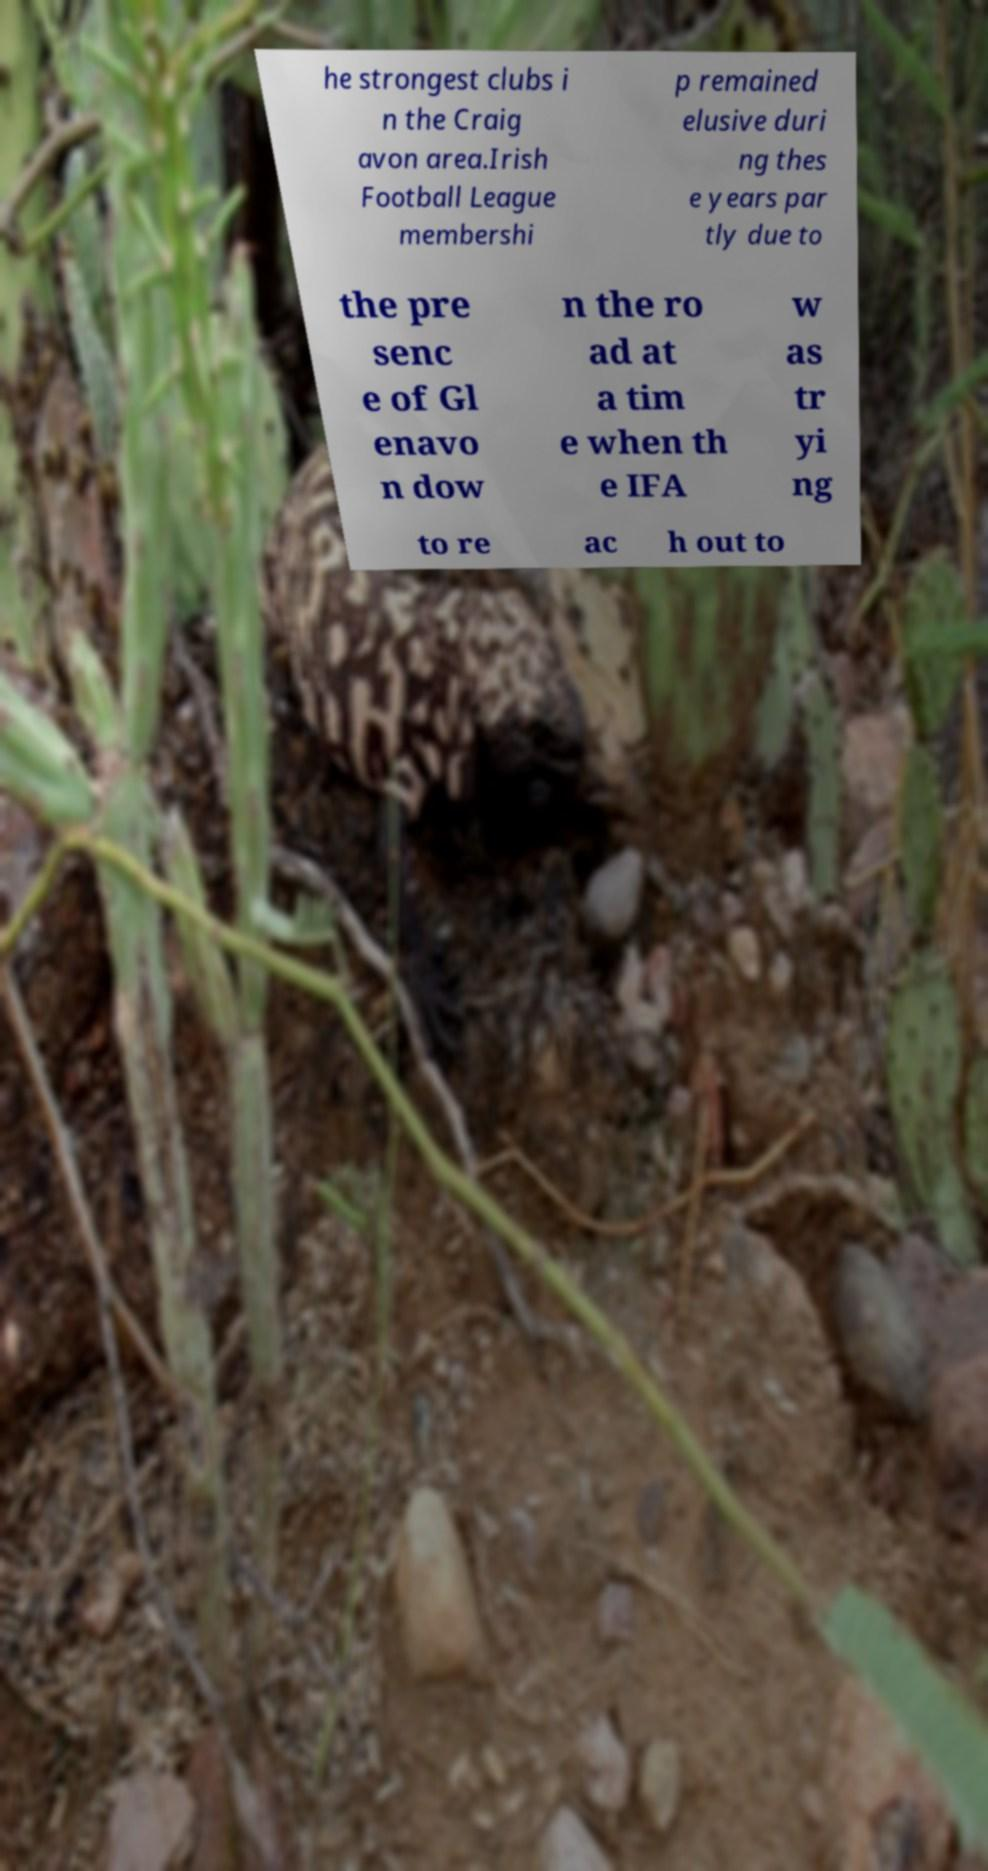There's text embedded in this image that I need extracted. Can you transcribe it verbatim? he strongest clubs i n the Craig avon area.Irish Football League membershi p remained elusive duri ng thes e years par tly due to the pre senc e of Gl enavo n dow n the ro ad at a tim e when th e IFA w as tr yi ng to re ac h out to 